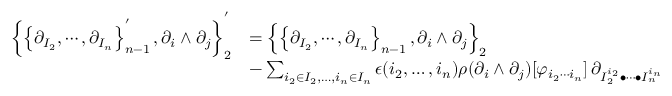<formula> <loc_0><loc_0><loc_500><loc_500>\begin{array} { r l } { \left \{ \left \{ \partial _ { I _ { 2 } } , \cdots , \partial _ { I _ { n } } \right \} _ { n - 1 } ^ { ^ { \prime } } , \partial _ { i } \wedge \partial _ { j } \right \} _ { 2 } ^ { ^ { \prime } } } & { = \left \{ \left \{ \partial _ { I _ { 2 } } , \cdots , \partial _ { I _ { n } } \right \} _ { n - 1 } , \partial _ { i } \wedge \partial _ { j } \right \} _ { 2 } } \\ & { - \sum _ { i _ { 2 } \in I _ { 2 } , \dots , i _ { n } \in I _ { n } } \epsilon ( i _ { 2 } , \dots , i _ { n } ) \rho ( \partial _ { i } \wedge \partial _ { j } ) [ \varphi _ { i _ { 2 } \cdots i _ { n } } ] \, \partial _ { I _ { 2 } ^ { i _ { 2 } } \bullet \cdots \bullet I _ { n } ^ { i _ { n } } } } \end{array}</formula> 